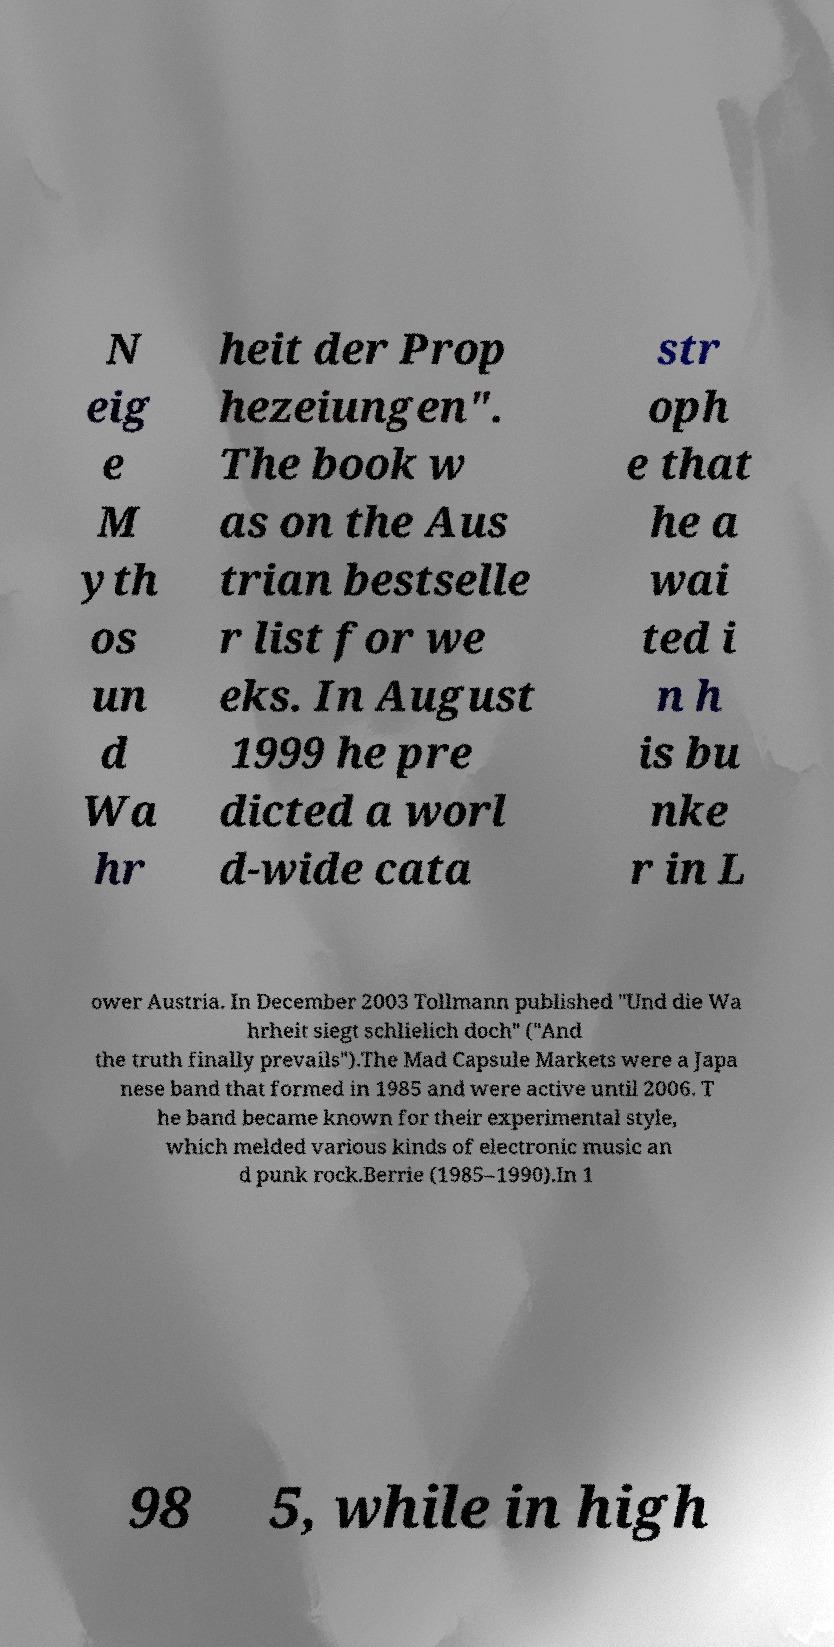Could you assist in decoding the text presented in this image and type it out clearly? N eig e M yth os un d Wa hr heit der Prop hezeiungen". The book w as on the Aus trian bestselle r list for we eks. In August 1999 he pre dicted a worl d-wide cata str oph e that he a wai ted i n h is bu nke r in L ower Austria. In December 2003 Tollmann published "Und die Wa hrheit siegt schlielich doch" ("And the truth finally prevails").The Mad Capsule Markets were a Japa nese band that formed in 1985 and were active until 2006. T he band became known for their experimental style, which melded various kinds of electronic music an d punk rock.Berrie (1985–1990).In 1 98 5, while in high 